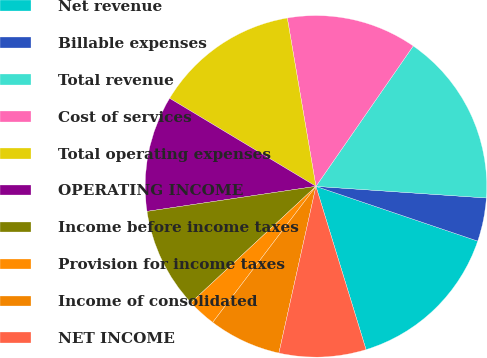Convert chart to OTSL. <chart><loc_0><loc_0><loc_500><loc_500><pie_chart><fcel>Net revenue<fcel>Billable expenses<fcel>Total revenue<fcel>Cost of services<fcel>Total operating expenses<fcel>OPERATING INCOME<fcel>Income before income taxes<fcel>Provision for income taxes<fcel>Income of consolidated<fcel>NET INCOME<nl><fcel>15.07%<fcel>4.11%<fcel>16.44%<fcel>12.33%<fcel>13.7%<fcel>10.96%<fcel>9.59%<fcel>2.74%<fcel>6.85%<fcel>8.22%<nl></chart> 